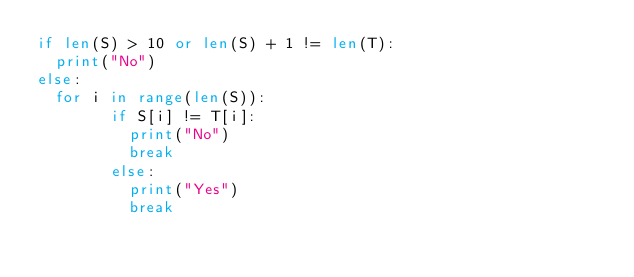Convert code to text. <code><loc_0><loc_0><loc_500><loc_500><_Python_>if len(S) > 10 or len(S) + 1 != len(T):
  print("No")
else:
  for i in range(len(S)):
        if S[i] != T[i]:
          print("No")
          break
        else:
          print("Yes")
          break</code> 